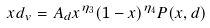Convert formula to latex. <formula><loc_0><loc_0><loc_500><loc_500>x d _ { v } = A _ { d } x ^ { \eta _ { 3 } } ( 1 - x ) ^ { \eta _ { 4 } } P ( x , d )</formula> 